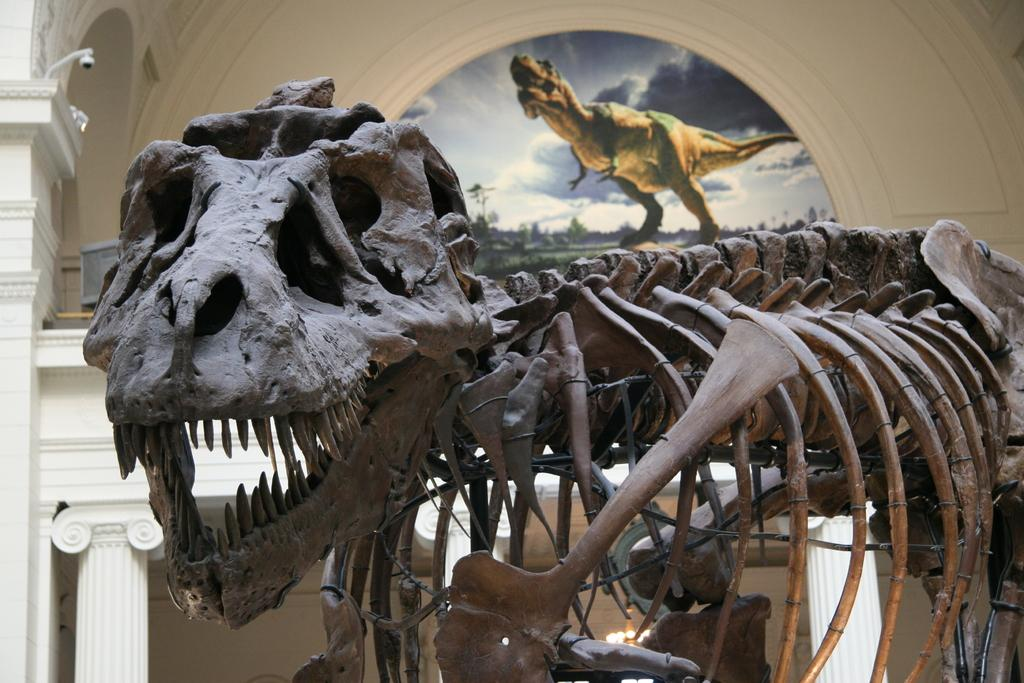What is the main subject of the image? There is a skeleton of a dinosaur in the image. What else can be seen in the image besides the dinosaur skeleton? There is a poster in the image. What type of location is depicted in the image? The image is an inner view of a room. What is the price of the dinosaur skeleton in the image? The image does not provide information about the price of the dinosaur skeleton, as it is not a sales advertisement or an auction. --- 